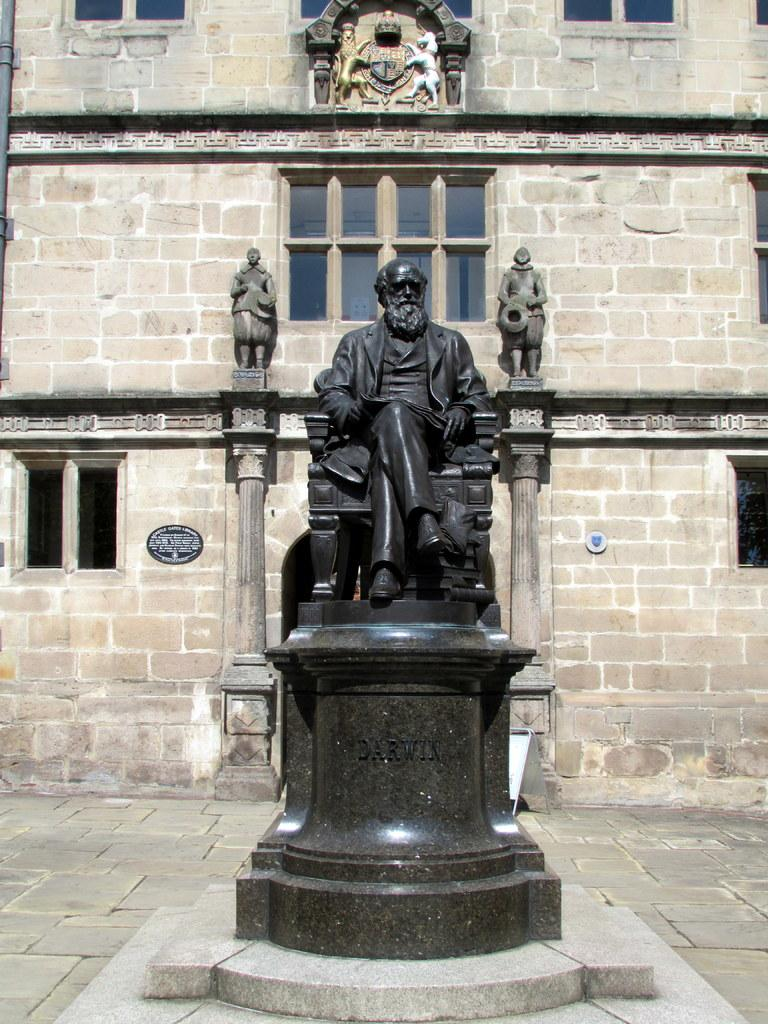What is the main subject in the center of the image? There is a statue in the center of the image. What can be seen in the background of the image? There is a building with windows and a board in the background. Are there any other statues visible in the image? Yes, there are statues on the wall of the building. What type of tail can be seen on the statue in the image? There is no tail present on the statue in the image. 